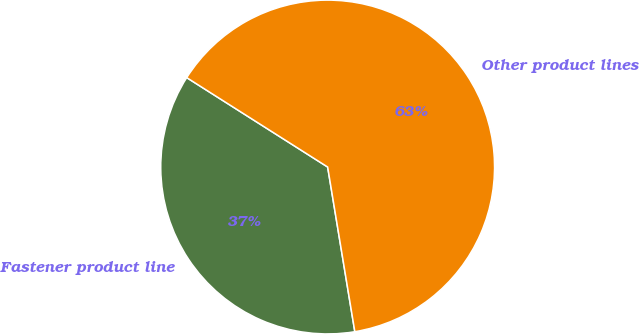Convert chart. <chart><loc_0><loc_0><loc_500><loc_500><pie_chart><fcel>Fastener product line<fcel>Other product lines<nl><fcel>36.6%<fcel>63.4%<nl></chart> 